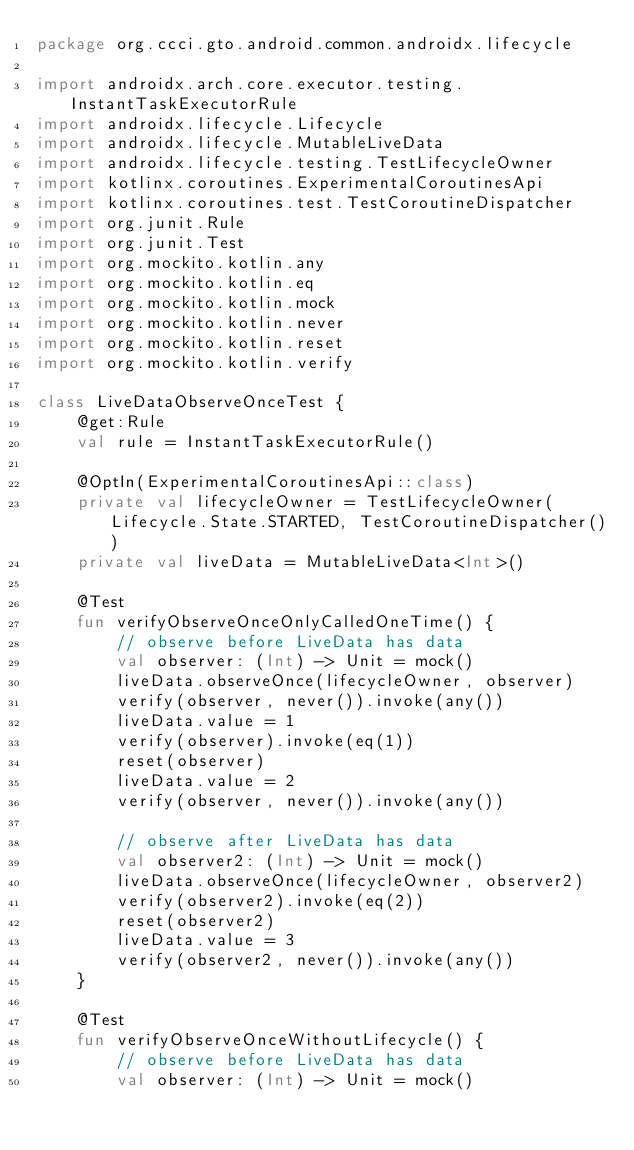<code> <loc_0><loc_0><loc_500><loc_500><_Kotlin_>package org.ccci.gto.android.common.androidx.lifecycle

import androidx.arch.core.executor.testing.InstantTaskExecutorRule
import androidx.lifecycle.Lifecycle
import androidx.lifecycle.MutableLiveData
import androidx.lifecycle.testing.TestLifecycleOwner
import kotlinx.coroutines.ExperimentalCoroutinesApi
import kotlinx.coroutines.test.TestCoroutineDispatcher
import org.junit.Rule
import org.junit.Test
import org.mockito.kotlin.any
import org.mockito.kotlin.eq
import org.mockito.kotlin.mock
import org.mockito.kotlin.never
import org.mockito.kotlin.reset
import org.mockito.kotlin.verify

class LiveDataObserveOnceTest {
    @get:Rule
    val rule = InstantTaskExecutorRule()

    @OptIn(ExperimentalCoroutinesApi::class)
    private val lifecycleOwner = TestLifecycleOwner(Lifecycle.State.STARTED, TestCoroutineDispatcher())
    private val liveData = MutableLiveData<Int>()

    @Test
    fun verifyObserveOnceOnlyCalledOneTime() {
        // observe before LiveData has data
        val observer: (Int) -> Unit = mock()
        liveData.observeOnce(lifecycleOwner, observer)
        verify(observer, never()).invoke(any())
        liveData.value = 1
        verify(observer).invoke(eq(1))
        reset(observer)
        liveData.value = 2
        verify(observer, never()).invoke(any())

        // observe after LiveData has data
        val observer2: (Int) -> Unit = mock()
        liveData.observeOnce(lifecycleOwner, observer2)
        verify(observer2).invoke(eq(2))
        reset(observer2)
        liveData.value = 3
        verify(observer2, never()).invoke(any())
    }

    @Test
    fun verifyObserveOnceWithoutLifecycle() {
        // observe before LiveData has data
        val observer: (Int) -> Unit = mock()</code> 